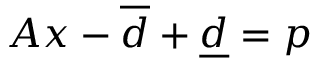<formula> <loc_0><loc_0><loc_500><loc_500>A x - \overline { d } + \underline { d } = p</formula> 